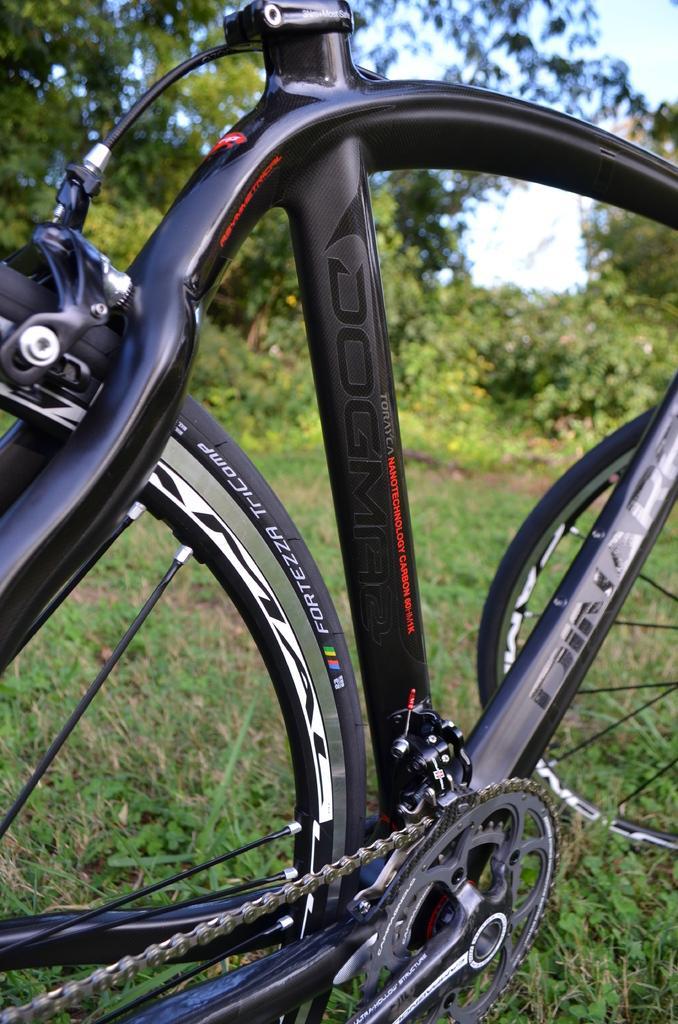Could you give a brief overview of what you see in this image? In this picture we can see a bicycle, grass and few trees. 